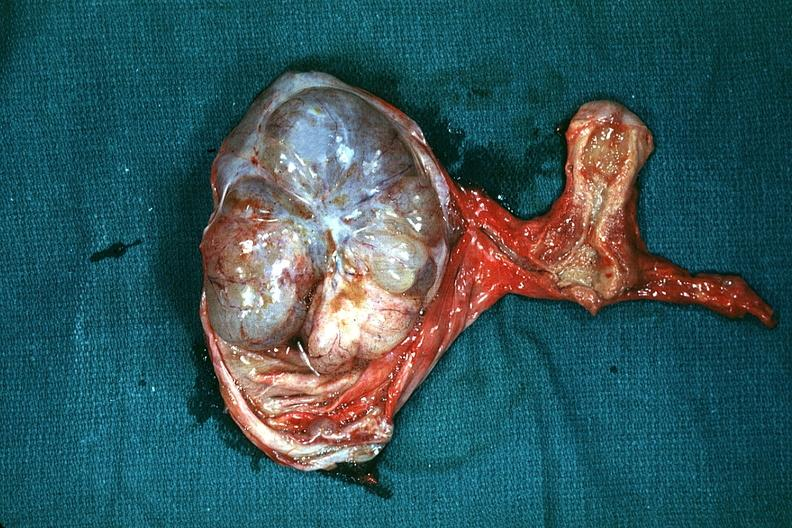s ovary present?
Answer the question using a single word or phrase. Yes 